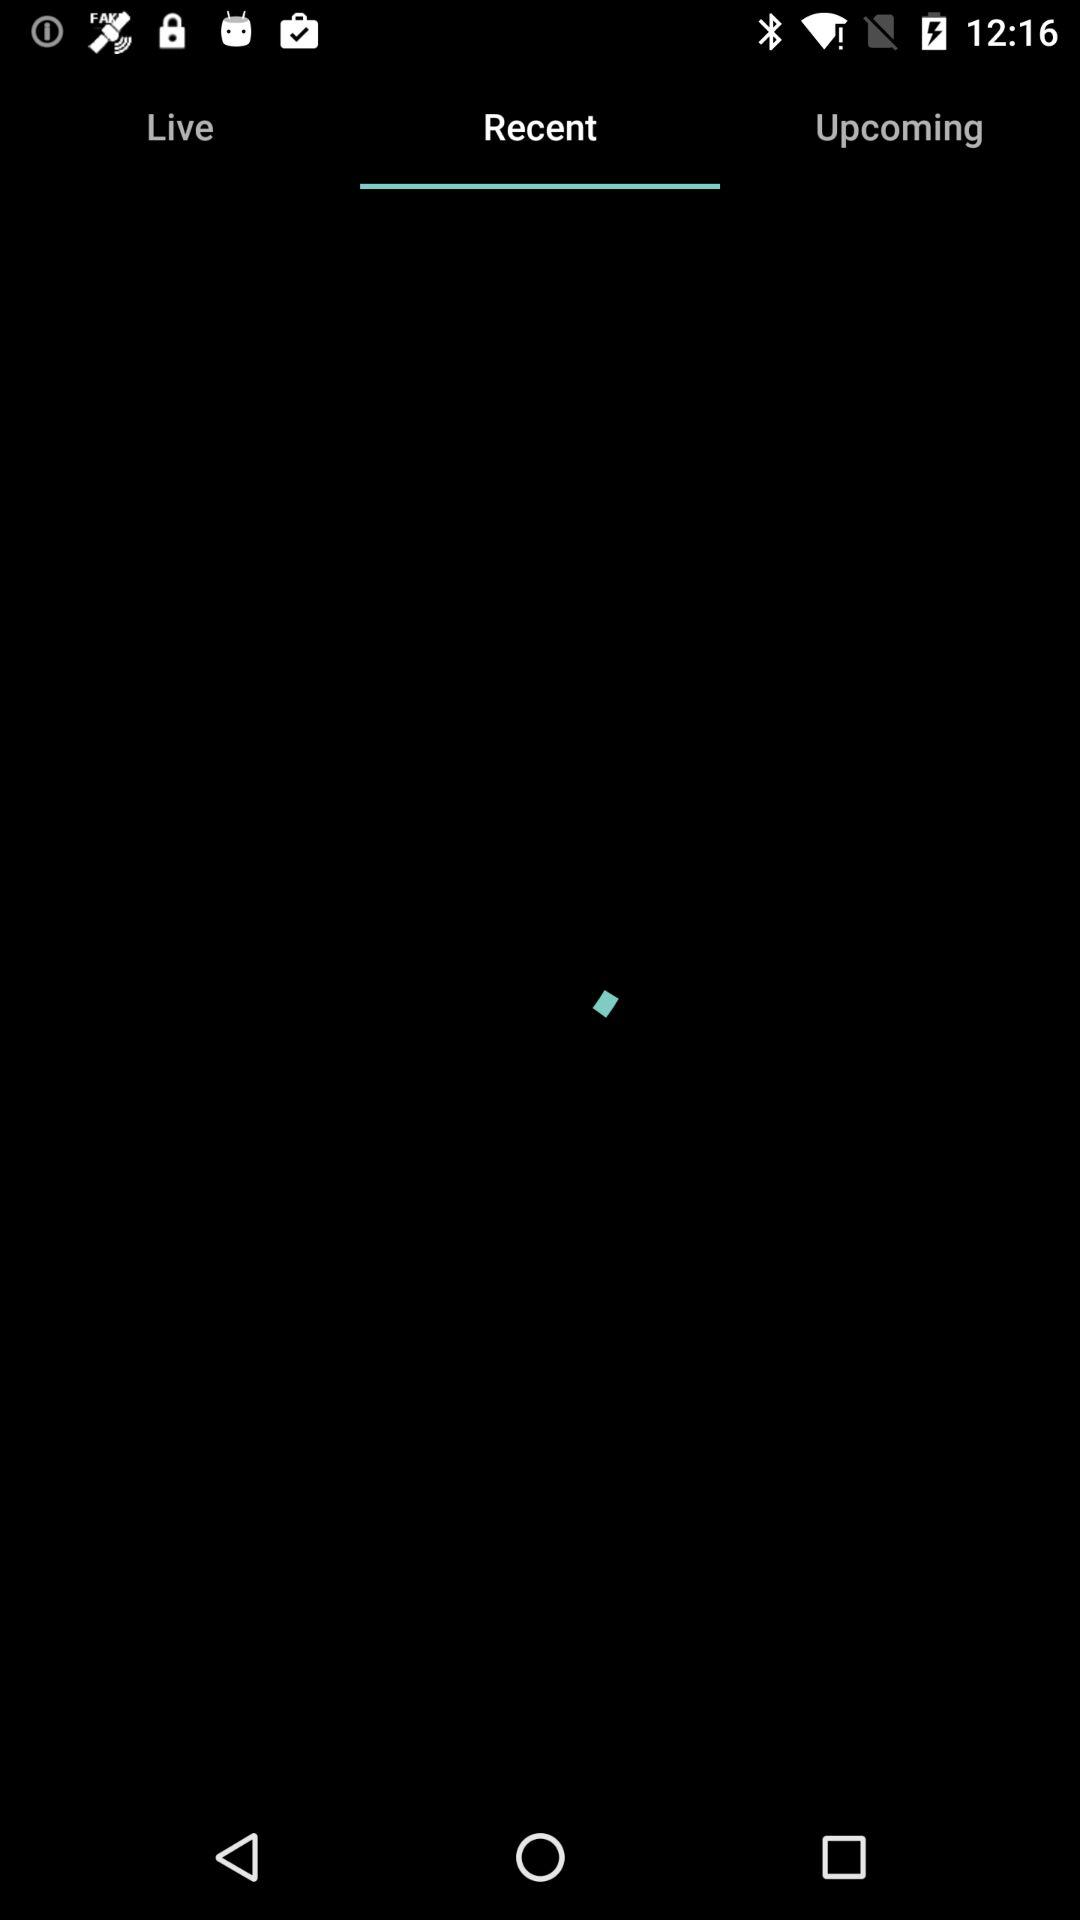Which tab am I on? You are on the "Recent" tab. 